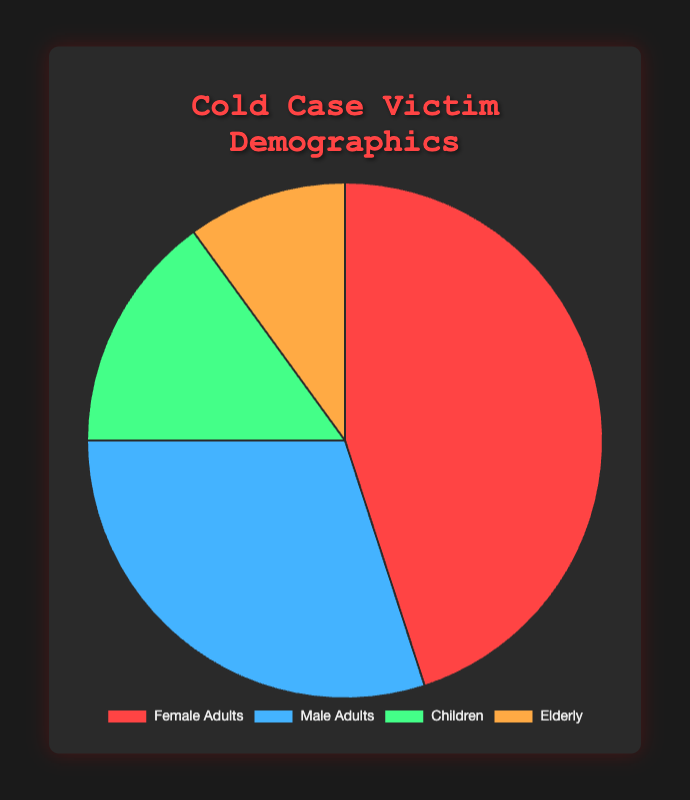What's the percentage of Female Adults victims? The pie chart indicates that the percentage of Female Adults victims is 45%. This can be directly read from the labeled sections.
Answer: 45% Which category has the smallest percentage of victims? By looking at the pie chart, the category with the smallest section corresponds to the Elderly, which has a percentage of 10%.
Answer: Elderly Are there more Male Adults or Children victims? Comparing the pie slices, the Male Adults section is larger than the Children section. The percentage for Male Adults is 30%, while it is only 15% for Children.
Answer: Male Adults What is the combined percentage of Children and Elderly victims? Sum the individual percentages for Children and Elderly: 15% + 10%.
Answer: 25% Which category has a higher percentage of victims, Female Adults or all other categories combined? Female Adults have 45%. The combined percentage of the other categories (Male Adults, Children, Elderly) is 30% + 15% + 10% = 55%. Therefore, the other categories combined have a higher percentage.
Answer: Other categories combined How much larger is the percentage of Female Adults compared to the percentage of Elderly? Subtract the percentage of Elderly from Female Adults: 45% - 10%.
Answer: 35% What percentage of victims are either Male Adults or Elderly? Add the percentages of Male Adults and Elderly: 30% + 10%.
Answer: 40% If you were to average the percentage of Children and Elderly victims, what would you get? Sum the percentages of Children and Elderly: 15% + 10%, then divide by 2. (15 + 10) / 2 = 12.5%
Answer: 12.5% Which segment is visually represented by a red color? Based on the chart's visual attributes, the segment represented by a red color corresponds to Female Adults.
Answer: Female Adults 